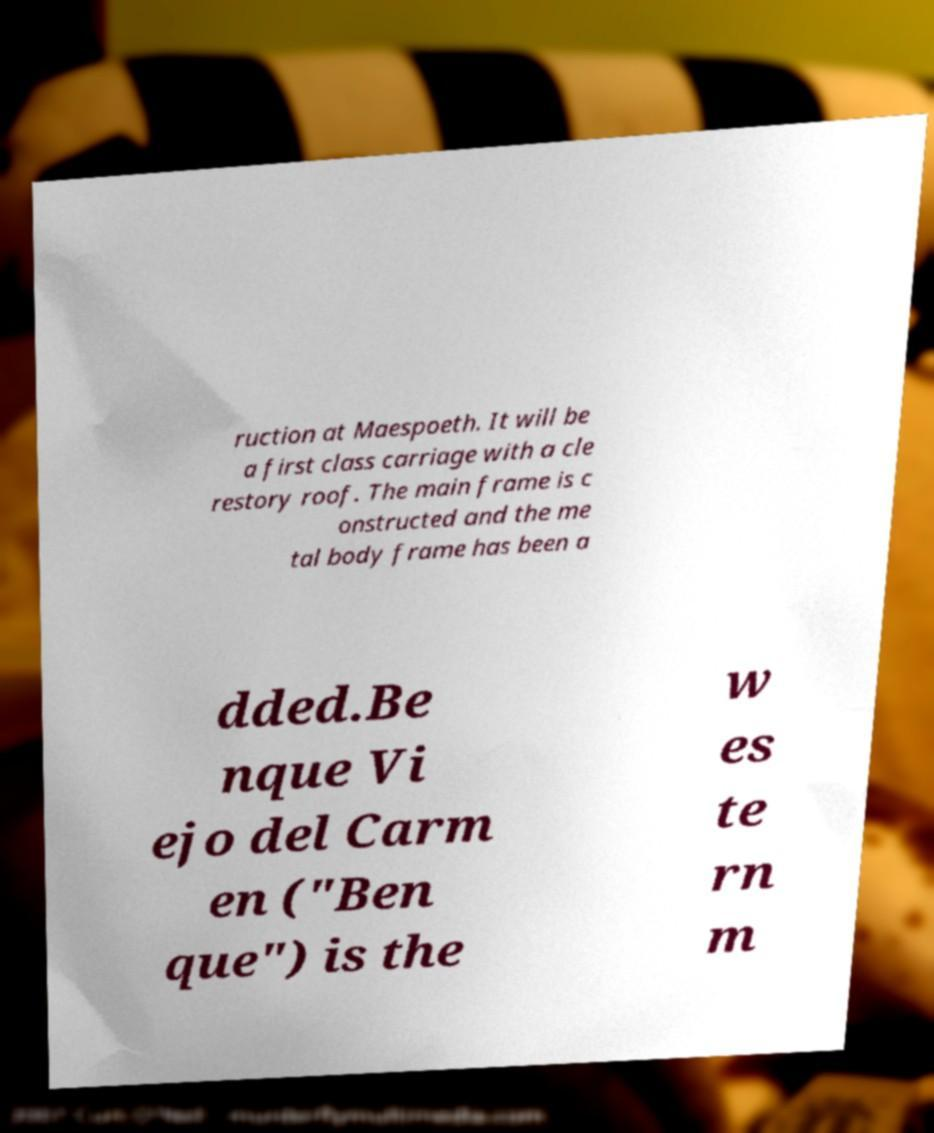Can you accurately transcribe the text from the provided image for me? ruction at Maespoeth. It will be a first class carriage with a cle restory roof. The main frame is c onstructed and the me tal body frame has been a dded.Be nque Vi ejo del Carm en ("Ben que") is the w es te rn m 